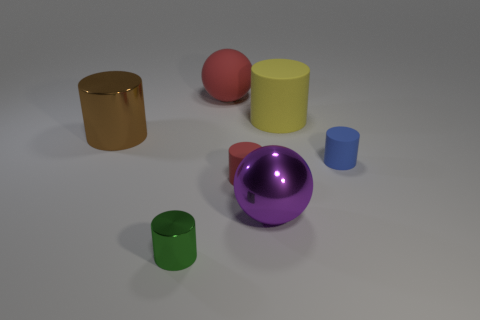Subtract all blue cylinders. How many cylinders are left? 4 Subtract all tiny red matte cylinders. How many cylinders are left? 4 Add 2 small matte things. How many objects exist? 9 Subtract all cyan cylinders. Subtract all red blocks. How many cylinders are left? 5 Subtract all balls. How many objects are left? 5 Add 5 big yellow matte cubes. How many big yellow matte cubes exist? 5 Subtract 0 purple cubes. How many objects are left? 7 Subtract all yellow objects. Subtract all tiny matte cylinders. How many objects are left? 4 Add 4 large matte cylinders. How many large matte cylinders are left? 5 